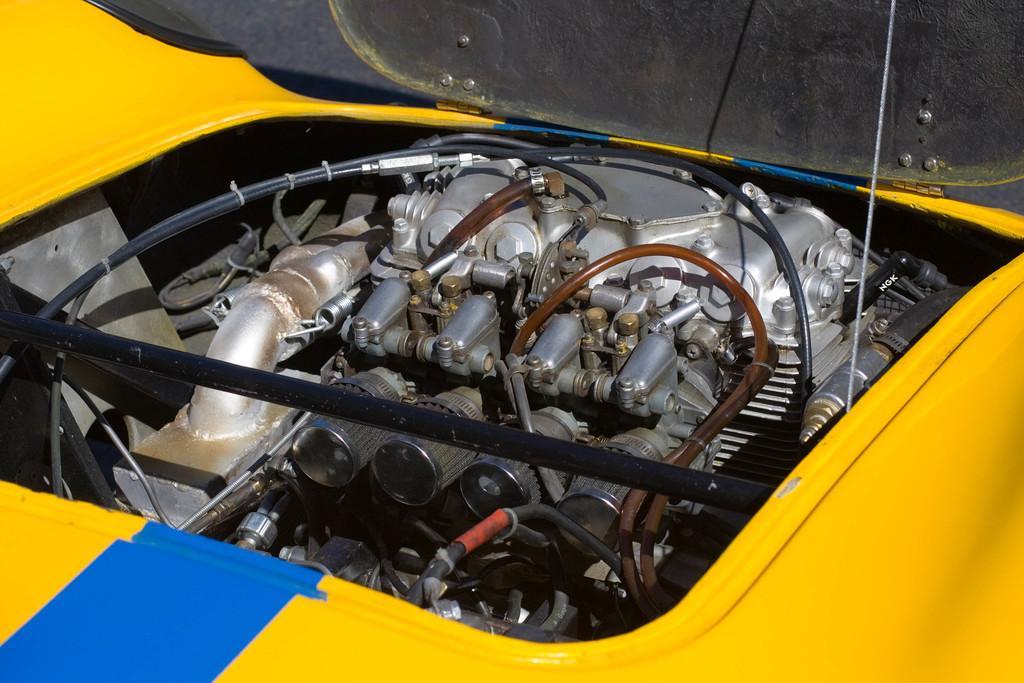In one or two sentences, can you explain what this image depicts? This is a picture of an engine of a vehicle. 